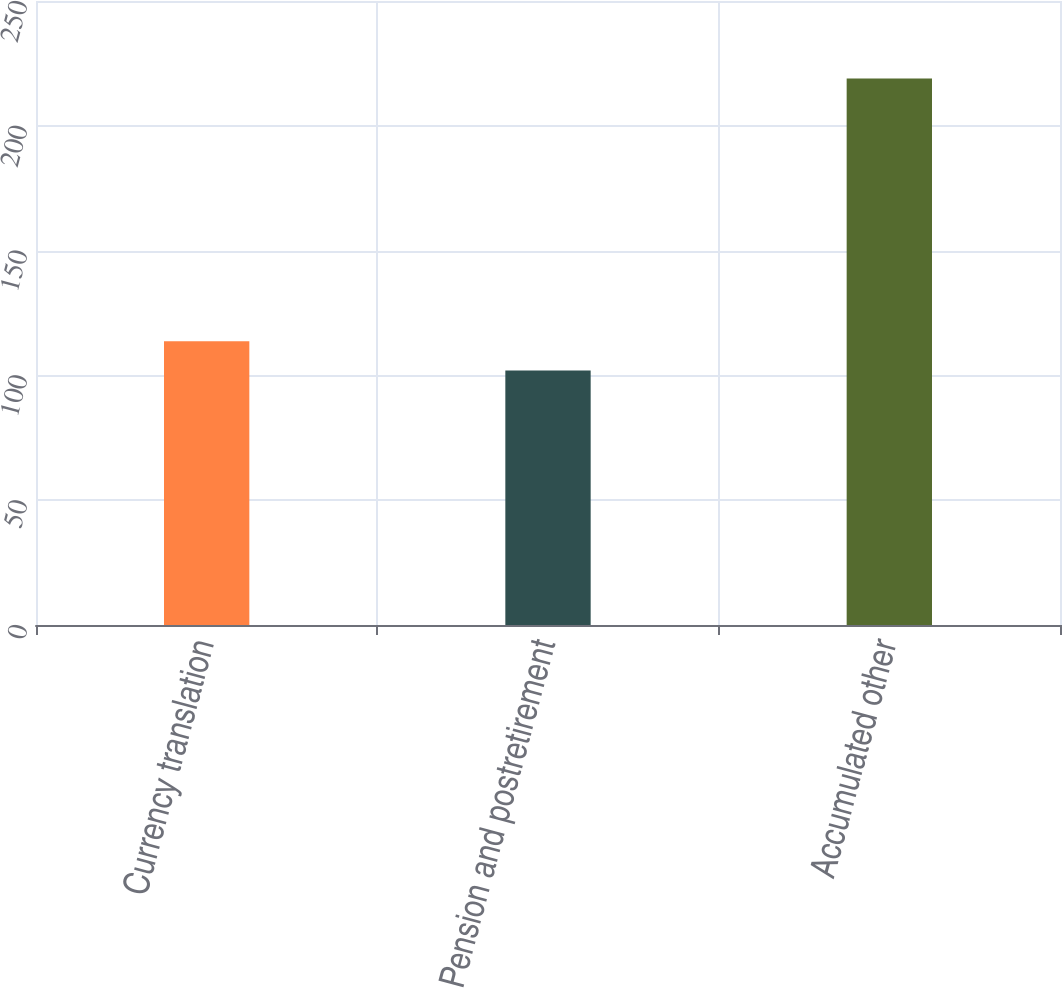Convert chart. <chart><loc_0><loc_0><loc_500><loc_500><bar_chart><fcel>Currency translation<fcel>Pension and postretirement<fcel>Accumulated other<nl><fcel>113.7<fcel>102<fcel>219<nl></chart> 